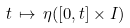Convert formula to latex. <formula><loc_0><loc_0><loc_500><loc_500>t \, \mapsto \, \eta ( [ 0 , t ] \times I )</formula> 